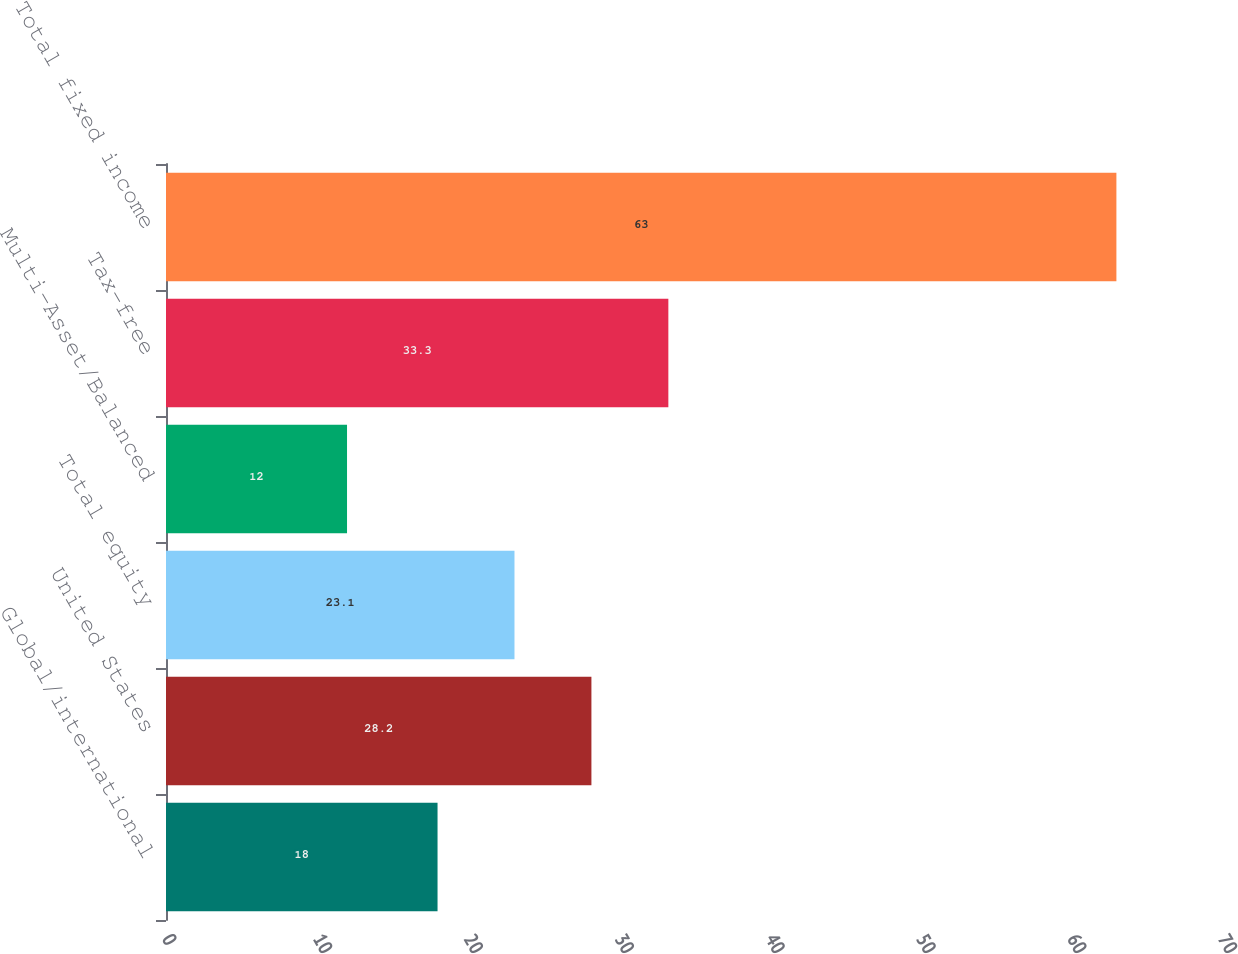Convert chart. <chart><loc_0><loc_0><loc_500><loc_500><bar_chart><fcel>Global/international<fcel>United States<fcel>Total equity<fcel>Multi-Asset/Balanced<fcel>Tax-free<fcel>Total fixed income<nl><fcel>18<fcel>28.2<fcel>23.1<fcel>12<fcel>33.3<fcel>63<nl></chart> 